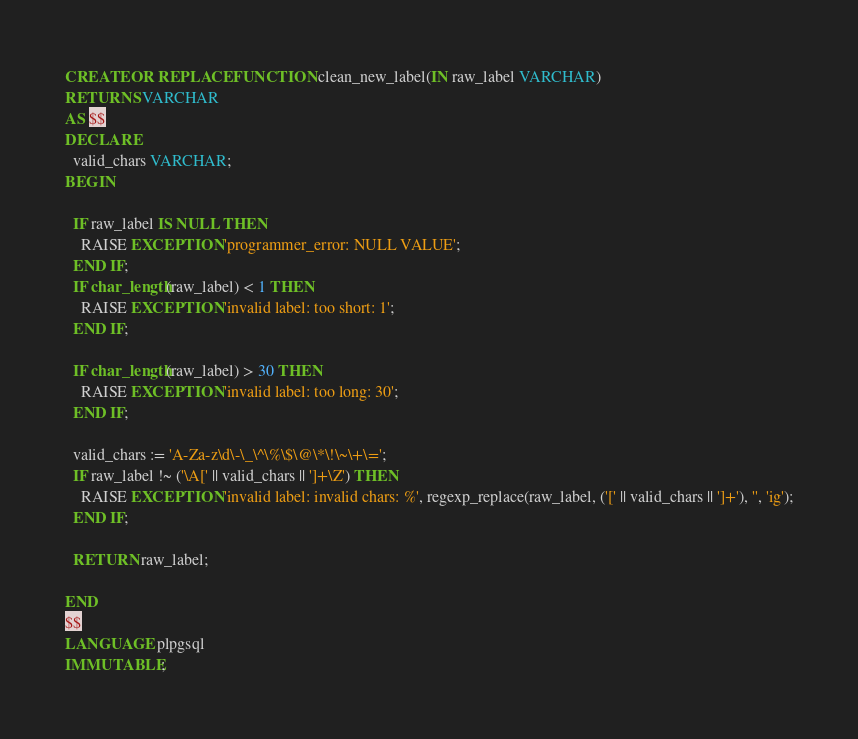Convert code to text. <code><loc_0><loc_0><loc_500><loc_500><_SQL_>
CREATE OR REPLACE FUNCTION clean_new_label(IN raw_label VARCHAR)
RETURNS VARCHAR
AS $$
DECLARE
  valid_chars VARCHAR;
BEGIN

  IF raw_label IS NULL THEN
    RAISE EXCEPTION 'programmer_error: NULL VALUE';
  END IF;
  IF char_length(raw_label) < 1 THEN
    RAISE EXCEPTION 'invalid label: too short: 1';
  END IF;

  IF char_length(raw_label) > 30 THEN
    RAISE EXCEPTION 'invalid label: too long: 30';
  END IF;

  valid_chars := 'A-Za-z\d\-\_\^\%\$\@\*\!\~\+\=';
  IF raw_label !~ ('\A[' || valid_chars || ']+\Z') THEN
    RAISE EXCEPTION 'invalid label: invalid chars: %', regexp_replace(raw_label, ('[' || valid_chars || ']+'), '', 'ig');
  END IF;

  RETURN raw_label;

END
$$
LANGUAGE plpgsql
IMMUTABLE;
</code> 